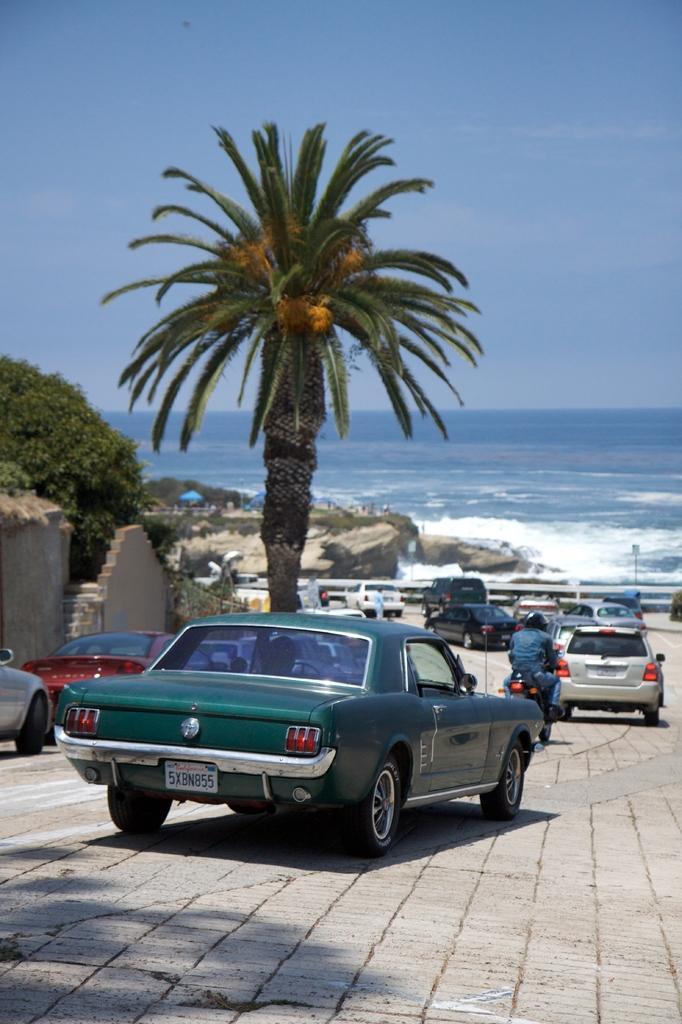Please provide a concise description of this image. At the bottom, we see the road. In the middle, we see the vehicles are moving on the road. Beside that, we see a tree. On the left side, we see the wall, staircase and the trees. In the middle, we see the railing, rocks and the trees. In the background, we see the water and this water might be in the sea. At the top, we see the sky, which is blue in color. 